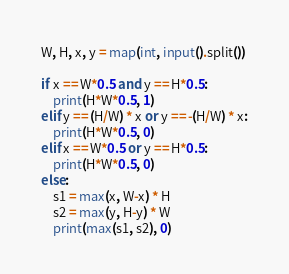Convert code to text. <code><loc_0><loc_0><loc_500><loc_500><_Python_>W, H, x, y = map(int, input().split())

if x == W*0.5 and y == H*0.5:
    print(H*W*0.5, 1)
elif y == (H/W) * x or y == -(H/W) * x:
    print(H*W*0.5, 0)
elif x == W*0.5 or y == H*0.5:
    print(H*W*0.5, 0)
else:
    s1 = max(x, W-x) * H
    s2 = max(y, H-y) * W
    print(max(s1, s2), 0)</code> 